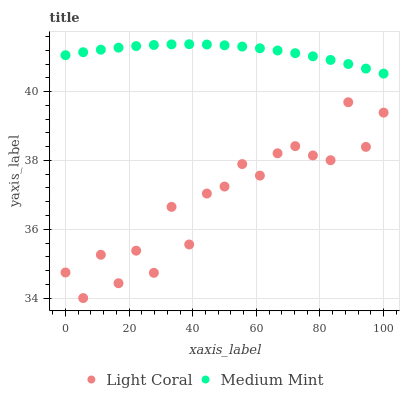Does Light Coral have the minimum area under the curve?
Answer yes or no. Yes. Does Medium Mint have the maximum area under the curve?
Answer yes or no. Yes. Does Medium Mint have the minimum area under the curve?
Answer yes or no. No. Is Medium Mint the smoothest?
Answer yes or no. Yes. Is Light Coral the roughest?
Answer yes or no. Yes. Is Medium Mint the roughest?
Answer yes or no. No. Does Light Coral have the lowest value?
Answer yes or no. Yes. Does Medium Mint have the lowest value?
Answer yes or no. No. Does Medium Mint have the highest value?
Answer yes or no. Yes. Is Light Coral less than Medium Mint?
Answer yes or no. Yes. Is Medium Mint greater than Light Coral?
Answer yes or no. Yes. Does Light Coral intersect Medium Mint?
Answer yes or no. No. 